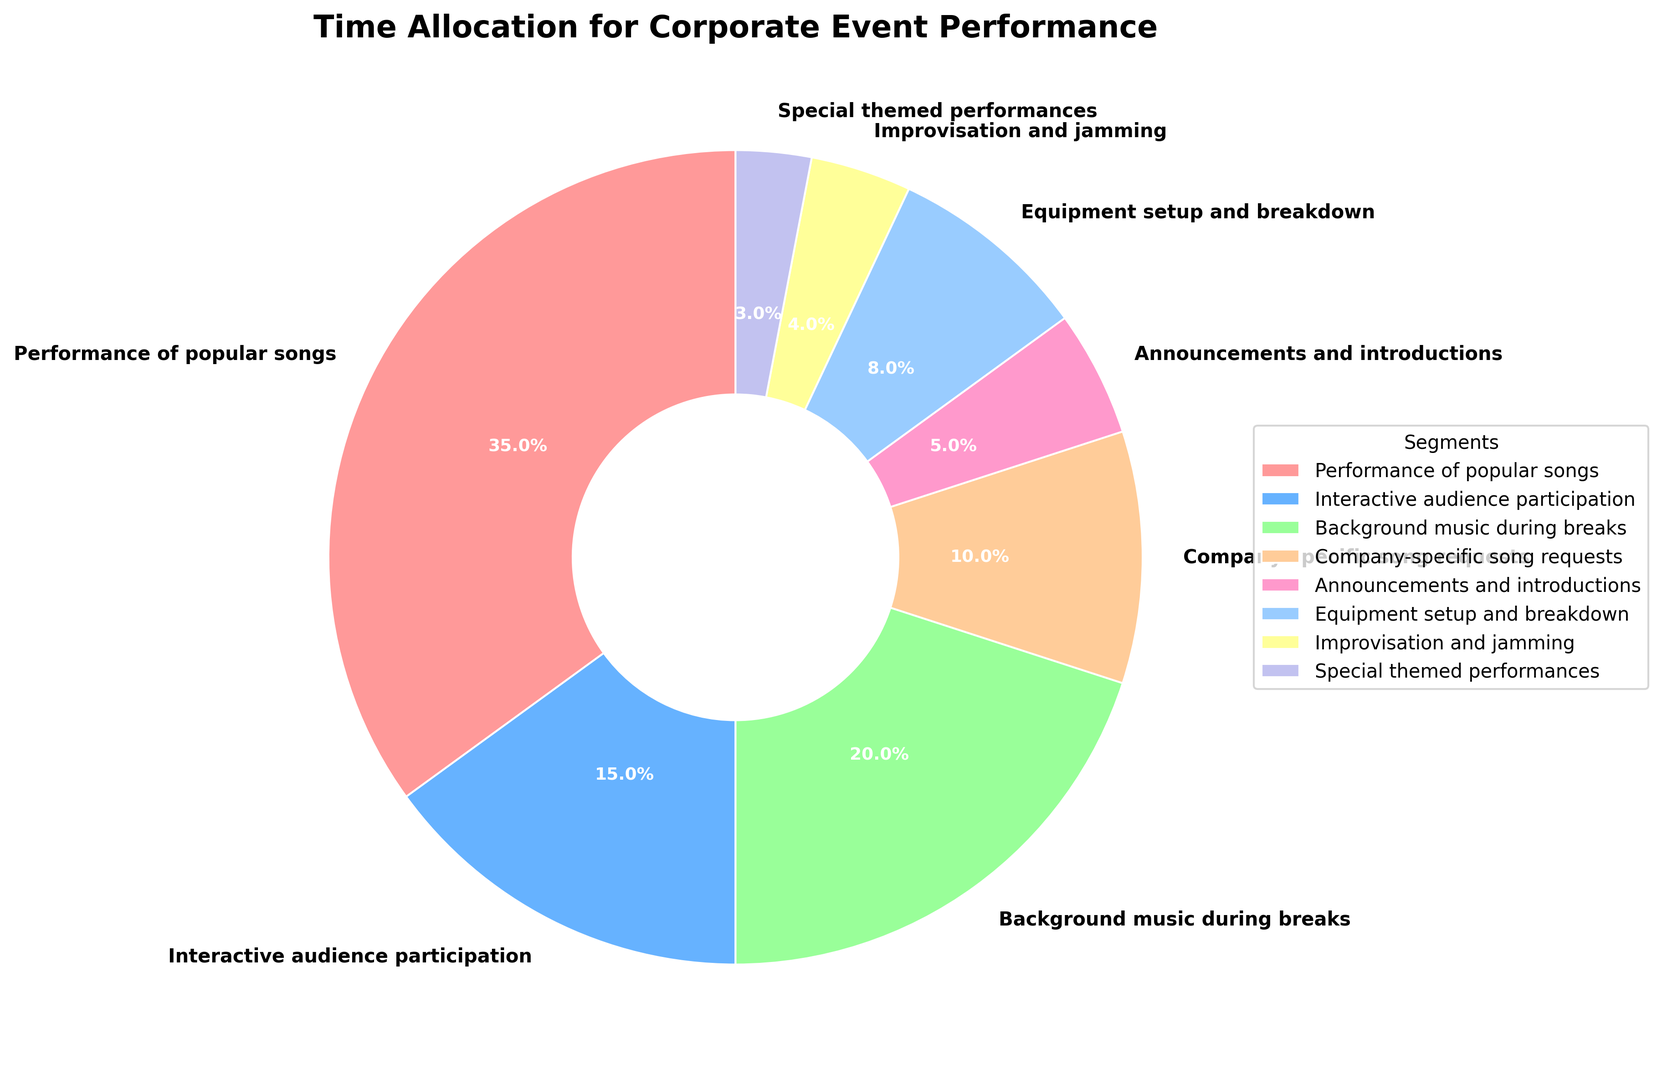What segment takes up the highest percentage of the time? To identify the segment with the highest percentage, we look for the largest wedge in the pie chart. The "Performance of popular songs" segment covers 35%, which is the highest.
Answer: Performance of popular songs What is the total percentage allocated to background music during breaks and announcements and introductions? We sum the percentages for "Background music during breaks" (20%) and "Announcements and introductions" (5%). Therefore, 20% + 5% = 25%.
Answer: 25% Which takes up more time: background music during breaks or interactive audience participation? By comparing the percentages, background music during breaks has 20% and interactive audience participation has 15%. Since 20% is greater than 15%, background music during breaks takes more time.
Answer: Background music during breaks How much more time is allocated to equipment setup and breakdown compared to special themed performances? The percentage for equipment setup and breakdown is 8% and for special themed performances is 3%. The difference is 8% - 3% = 5%.
Answer: 5% What is the average percentage of the time spent on performance of popular songs, company-specific song requests, and improvisation and jamming? We sum the percentages for these segments and divide by the number of segments. (35% + 10% + 4%) / 3 = 49% / 3 ≈ 16.33%.
Answer: 16.33% Is the percentage of time allocated to improvisation and jamming greater or less than special themed performances? By comparing the percentages, improvisation and jamming is 4%, whereas special themed performances is 3%. Since 4% is greater than 3%, improvisation and jamming has a greater percentage.
Answer: Greater Which two segments together make up exactly 25% of the total time? By inspecting the wedges, "Interactive audience participation" is 15% and "Announcements and introductions" is 5%. Together, they account for 15% + 5% = 20%. Checking other segments, we find that "Equipment setup and breakdown" is 8% and "Company-specific song requests" is 10%. A more detailed exploration will not show any two segments making exactly 25%.
Answer: None What is the combined percentage of segments that are below 10%? Summing the percentages of segments below 10%: "Company-specific song requests" (10%), "Announcements and introductions" (5%), "Equipment setup and breakdown" (8%), "Improvisation and jamming" (4%), "Special themed performances" (3%). Therefore, 10% + 5% + 8% + 4% + 3% = 30%.
Answer: 30% What color is used for the "Performance of popular songs" segment? The "Performance of popular songs" segment is represented by the first color in the given array, which is typically a shade of red.
Answer: Red 